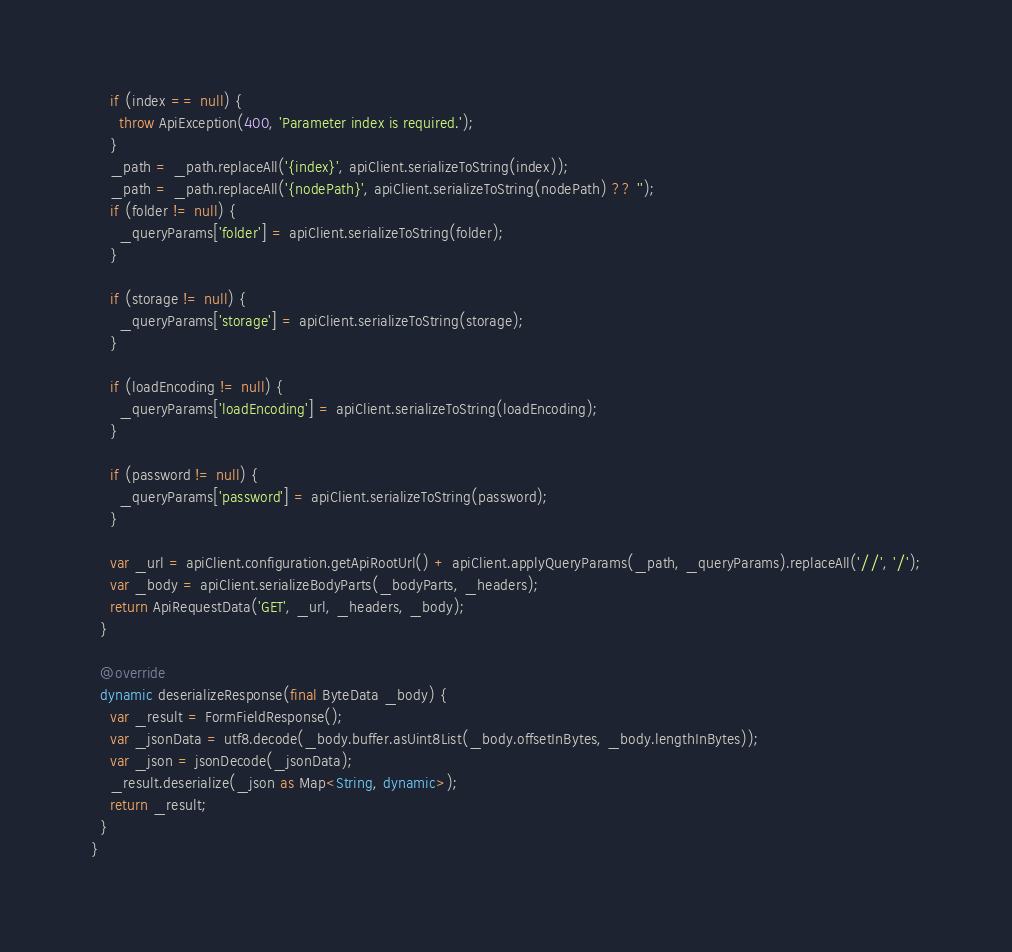<code> <loc_0><loc_0><loc_500><loc_500><_Dart_>    if (index == null) {
      throw ApiException(400, 'Parameter index is required.');
    }
    _path = _path.replaceAll('{index}', apiClient.serializeToString(index));
    _path = _path.replaceAll('{nodePath}', apiClient.serializeToString(nodePath) ?? '');
    if (folder != null) {
      _queryParams['folder'] = apiClient.serializeToString(folder);
    }

    if (storage != null) {
      _queryParams['storage'] = apiClient.serializeToString(storage);
    }

    if (loadEncoding != null) {
      _queryParams['loadEncoding'] = apiClient.serializeToString(loadEncoding);
    }

    if (password != null) {
      _queryParams['password'] = apiClient.serializeToString(password);
    }

    var _url = apiClient.configuration.getApiRootUrl() + apiClient.applyQueryParams(_path, _queryParams).replaceAll('//', '/');
    var _body = apiClient.serializeBodyParts(_bodyParts, _headers);
    return ApiRequestData('GET', _url, _headers, _body);
  }

  @override
  dynamic deserializeResponse(final ByteData _body) {
    var _result = FormFieldResponse();
    var _jsonData = utf8.decode(_body.buffer.asUint8List(_body.offsetInBytes, _body.lengthInBytes));
    var _json = jsonDecode(_jsonData);
    _result.deserialize(_json as Map<String, dynamic>);
    return _result;
  }
}</code> 